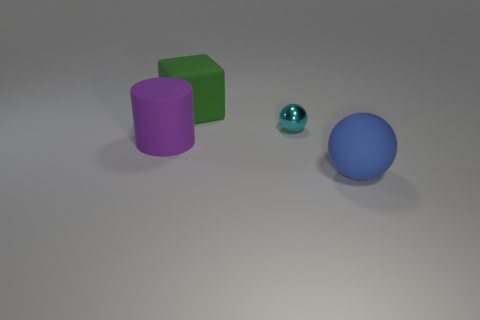Can you describe the shapes and their colors in this image? Certainly! In the image, we have three distinct shapes: a purple cylinder, a green cube, and two spheres - a larger blue one and a smaller teal one. They are arranged on a light gray surface, with a soft light creating subtle shadows. Do the shadows tell us anything about the light source? Yes, the shadows are soft and extended, suggesting that the light source is not too close to the objects. Also, since the shadows fall mostly to the right, the light source is likely coming from the left side. 